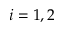<formula> <loc_0><loc_0><loc_500><loc_500>i = 1 , 2</formula> 